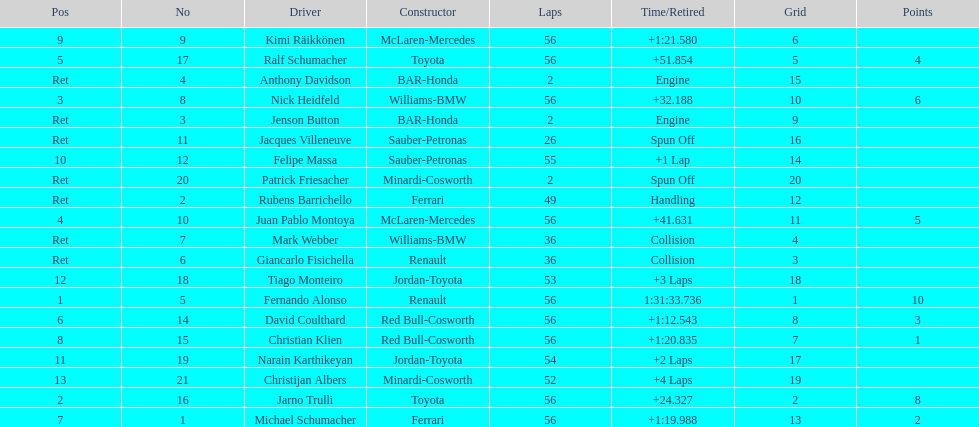Who was fernando alonso's instructor? Renault. How many laps did fernando alonso run? 56. How long did it take alonso to complete the race? 1:31:33.736. 